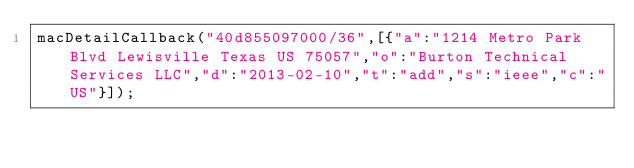Convert code to text. <code><loc_0><loc_0><loc_500><loc_500><_JavaScript_>macDetailCallback("40d855097000/36",[{"a":"1214 Metro Park Blvd Lewisville Texas US 75057","o":"Burton Technical Services LLC","d":"2013-02-10","t":"add","s":"ieee","c":"US"}]);
</code> 